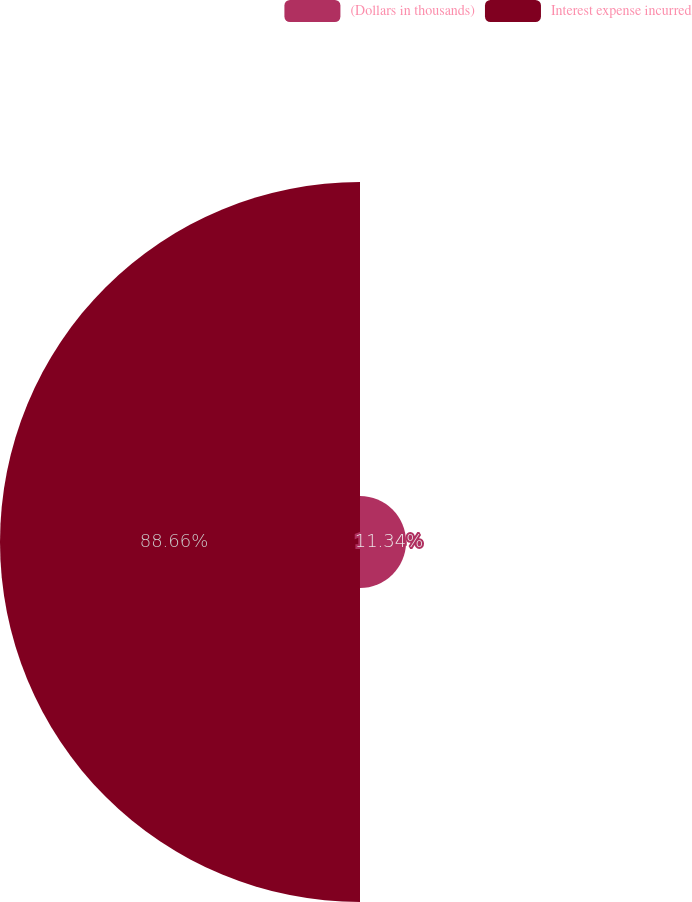Convert chart. <chart><loc_0><loc_0><loc_500><loc_500><pie_chart><fcel>(Dollars in thousands)<fcel>Interest expense incurred<nl><fcel>11.34%<fcel>88.66%<nl></chart> 